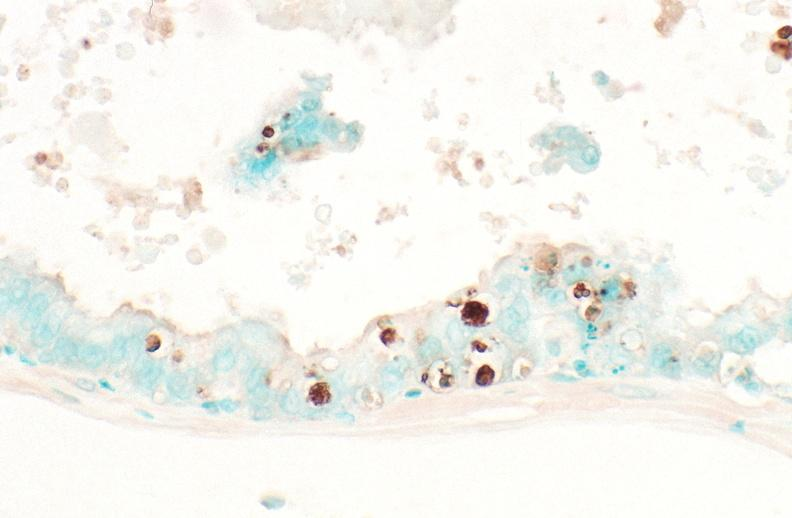what stain?
Answer the question using a single word or phrase. Apoptosis tunel 